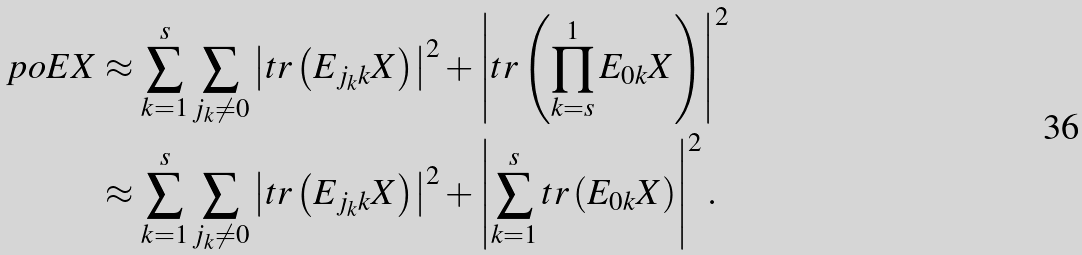<formula> <loc_0><loc_0><loc_500><loc_500>\ p o { E X } & \approx \sum _ { k = 1 } ^ { s } \sum _ { j _ { k } \neq 0 } \left | t r \left ( E _ { j _ { k } k } X \right ) \right | ^ { 2 } + \left | t r \left ( \prod _ { k = s } ^ { 1 } E _ { 0 k } X \right ) \right | ^ { 2 } \\ & \approx \sum _ { k = 1 } ^ { s } \sum _ { j _ { k } \neq 0 } \left | t r \left ( E _ { j _ { k } k } X \right ) \right | ^ { 2 } + \left | \sum _ { k = 1 } ^ { s } t r \left ( E _ { 0 k } X \right ) \right | ^ { 2 } .</formula> 